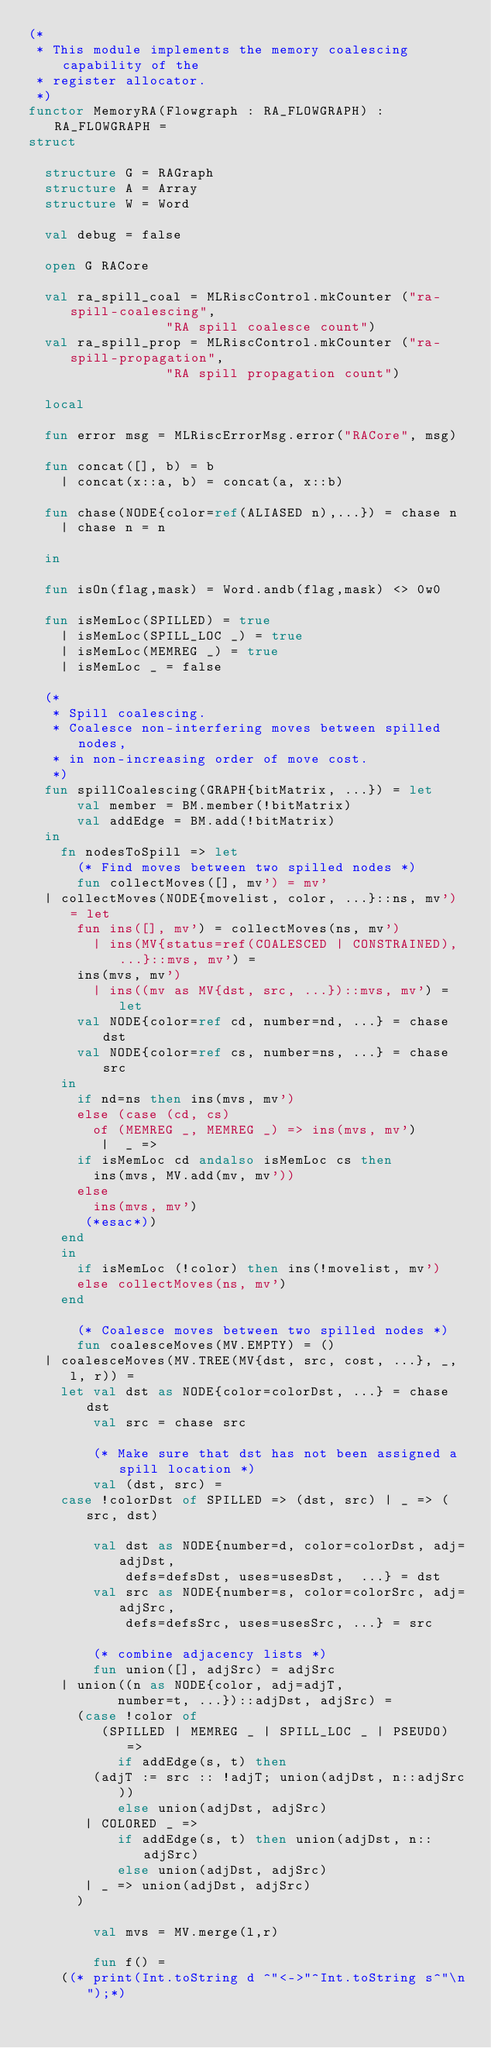Convert code to text. <code><loc_0><loc_0><loc_500><loc_500><_SML_>(* 
 * This module implements the memory coalescing capability of the 
 * register allocator.
 *)
functor MemoryRA(Flowgraph : RA_FLOWGRAPH) : RA_FLOWGRAPH =
struct

  structure G = RAGraph
  structure A = Array
  structure W = Word

  val debug = false

  open G RACore

  val ra_spill_coal = MLRiscControl.mkCounter ("ra-spill-coalescing",
					       "RA spill coalesce count")
  val ra_spill_prop = MLRiscControl.mkCounter ("ra-spill-propagation",
					       "RA spill propagation count")

  local

  fun error msg = MLRiscErrorMsg.error("RACore", msg)
 
  fun concat([], b) = b
    | concat(x::a, b) = concat(a, x::b)

  fun chase(NODE{color=ref(ALIASED n),...}) = chase n
    | chase n = n

  in

  fun isOn(flag,mask) = Word.andb(flag,mask) <> 0w0

  fun isMemLoc(SPILLED) = true
    | isMemLoc(SPILL_LOC _) = true
    | isMemLoc(MEMREG _) = true
    | isMemLoc _ = false

  (*
   * Spill coalescing.
   * Coalesce non-interfering moves between spilled nodes, 
   * in non-increasing order of move cost.
   *)
  fun spillCoalescing(GRAPH{bitMatrix, ...}) = let
      val member = BM.member(!bitMatrix)
      val addEdge = BM.add(!bitMatrix)
  in 
    fn nodesToSpill => let
      (* Find moves between two spilled nodes *)
      fun collectMoves([], mv') = mv'
	| collectMoves(NODE{movelist, color, ...}::ns, mv') = let
	    fun ins([], mv') = collectMoves(ns, mv')
	      | ins(MV{status=ref(COALESCED | CONSTRAINED), ...}::mvs, mv') = 
		  ins(mvs, mv')
	      | ins((mv as MV{dst, src, ...})::mvs, mv') = let
		  val NODE{color=ref cd, number=nd, ...} = chase dst
		  val NODE{color=ref cs, number=ns, ...} = chase src
		in
		  if nd=ns then ins(mvs, mv')
		  else (case (cd, cs)
		    of (MEMREG _, MEMREG _) => ins(mvs, mv')
		     |  _ => 
			if isMemLoc cd andalso isMemLoc cs then
			  ins(mvs, MV.add(mv, mv'))
			else
			  ins(mvs, mv')
		   (*esac*))
		end
	  in 
	    if isMemLoc (!color) then ins(!movelist, mv')
	    else collectMoves(ns, mv')
	  end

      (* Coalesce moves between two spilled nodes *)
      fun coalesceMoves(MV.EMPTY) = ()
	| coalesceMoves(MV.TREE(MV{dst, src, cost, ...}, _, l, r)) =
	  let val dst as NODE{color=colorDst, ...} = chase dst
	      val src = chase src

	      (* Make sure that dst has not been assigned a spill location *)
	      val (dst, src) =
		case !colorDst of SPILLED => (dst, src) | _ => (src, dst)

	      val dst as NODE{number=d, color=colorDst, adj=adjDst, 
			      defs=defsDst, uses=usesDst,  ...} = dst
	      val src as NODE{number=s, color=colorSrc, adj=adjSrc, 
			      defs=defsSrc, uses=usesSrc, ...} = src

	      (* combine adjacency lists *)
	      fun union([], adjSrc) = adjSrc
		| union((n as NODE{color, adj=adjT, 
				   number=t, ...})::adjDst, adjSrc) = 
		  (case !color of
		     (SPILLED | MEMREG _ | SPILL_LOC _ | PSEUDO) =>
		       if addEdge(s, t) then 
			  (adjT := src :: !adjT; union(adjDst, n::adjSrc))
		       else union(adjDst, adjSrc)
		   | COLORED _ =>
		       if addEdge(s, t) then union(adjDst, n::adjSrc) 
		       else union(adjDst, adjSrc)
		   | _ => union(adjDst, adjSrc)
		  )

	      val mvs = MV.merge(l,r)

	      fun f() = 
		((* print(Int.toString d ^"<->"^Int.toString s^"\n");*)</code> 